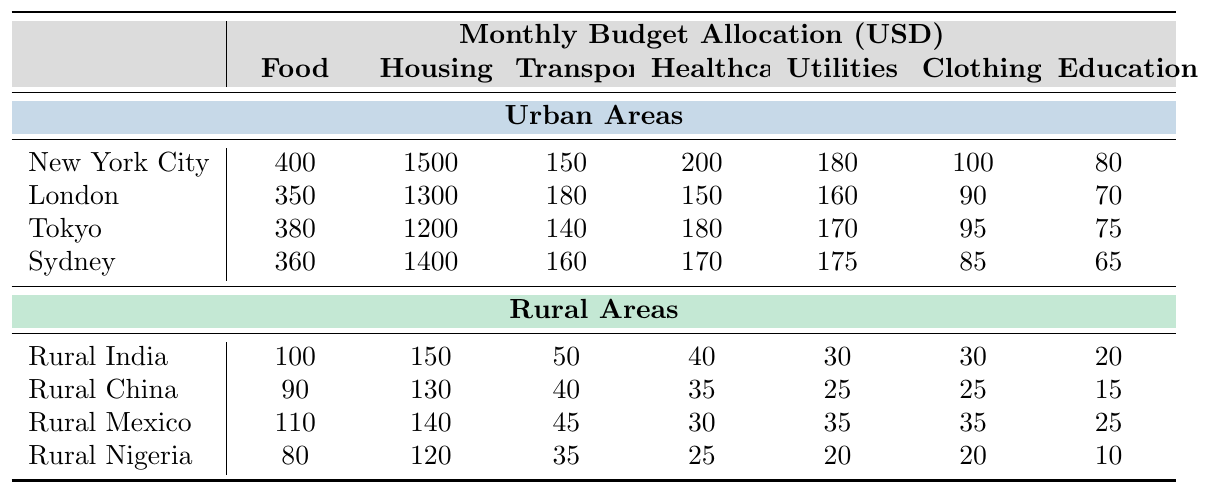What is the highest budget allocation for housing in urban areas? The table shows the housing budgets for various urban cities. New York City has the highest allocation at 1500 USD.
Answer: 1500 Which rural area has the highest allocation for healthcare? Among the rural areas listed, Rural India has the highest allocation for healthcare at 40 USD.
Answer: 40 What is the average monthly budget for food in urban areas? The food budgets for urban areas are 400, 350, 380, and 360. Summing these gives 1490, and dividing by 4 gives an average of 372.5.
Answer: 372.5 Is the transportation budget in Rural Nigeria higher than in Rural China? Rural Nigeria has a transportation budget of 35, and Rural China has 40. Since 35 is less than 40, the statement is false.
Answer: No What is the total budget allocation for utilities in urban areas? The utilities budgets in urban areas are 180, 160, 170, and 175. Summing these gives 685 USD.
Answer: 685 Which urban area spends the least on clothing? The clothing budgets for urban areas are 100, 90, 95, and 85. The lowest value is in Sydney at 85 USD.
Answer: Sydney If we compare the average spending on education between urban and rural areas, which is higher? The average education budget in urban areas is calculated as (80 + 70 + 75 + 65)/4 = 72.5. In rural areas, it's (20 + 15 + 25 + 10)/4 = 17.5. Since 72.5 > 17.5, urban areas spend more.
Answer: Urban areas What is the difference in budget allocation for food between New York City and Rural India? The food allocation for New York City is 400, and for Rural India it is 100. The difference is 400 - 100 = 300.
Answer: 300 How much more is spent on housing in Tokyo compared to Rural Mexico? The allocation for housing in Tokyo is 1200, while in Rural Mexico it is 140. The difference is 1200 - 140 = 1060.
Answer: 1060 Does any urban area spend less than 100 USD on utilities? The utilities budgets in urban areas are all above 100: New York City (180), London (160), Tokyo (170), and Sydney (175), hence the answer is no.
Answer: No 